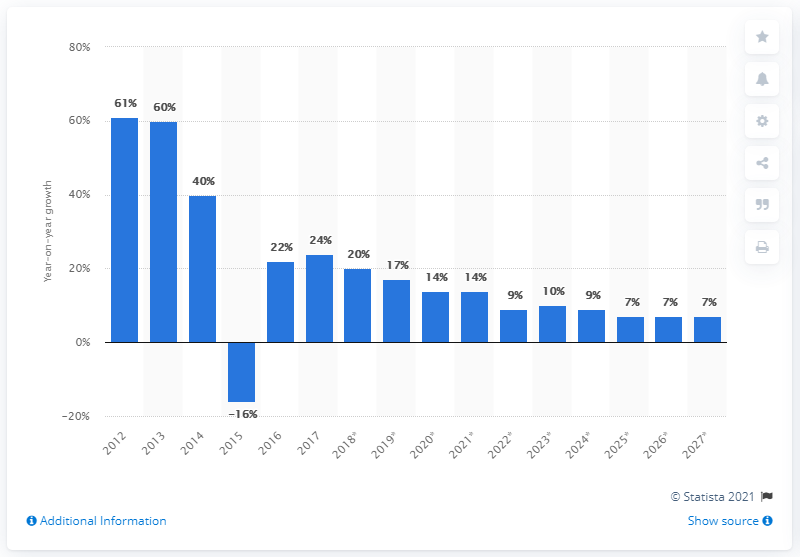Highlight a few significant elements in this photo. The big data market is expected to increase by a significant percentage in 2018. 